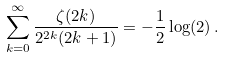<formula> <loc_0><loc_0><loc_500><loc_500>\sum _ { k = 0 } ^ { \infty } \frac { \zeta ( 2 k ) } { 2 ^ { 2 k } ( 2 k + 1 ) } = - \frac { 1 } { 2 } \log ( 2 ) \, .</formula> 